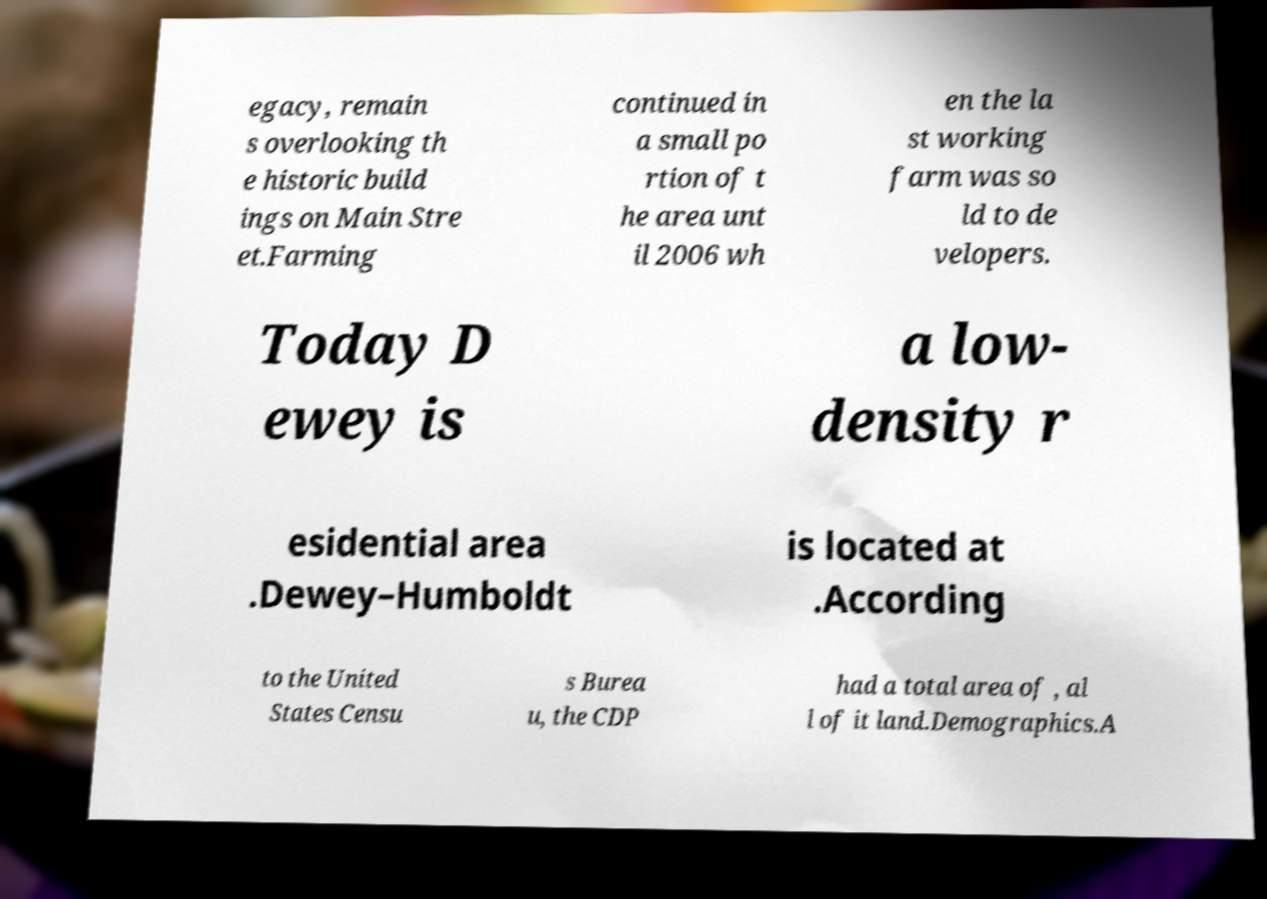What messages or text are displayed in this image? I need them in a readable, typed format. egacy, remain s overlooking th e historic build ings on Main Stre et.Farming continued in a small po rtion of t he area unt il 2006 wh en the la st working farm was so ld to de velopers. Today D ewey is a low- density r esidential area .Dewey–Humboldt is located at .According to the United States Censu s Burea u, the CDP had a total area of , al l of it land.Demographics.A 